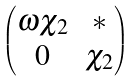Convert formula to latex. <formula><loc_0><loc_0><loc_500><loc_500>\begin{pmatrix} \omega \chi _ { 2 } & { * } \\ 0 & \chi _ { 2 } \end{pmatrix}</formula> 